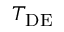Convert formula to latex. <formula><loc_0><loc_0><loc_500><loc_500>T _ { D E }</formula> 